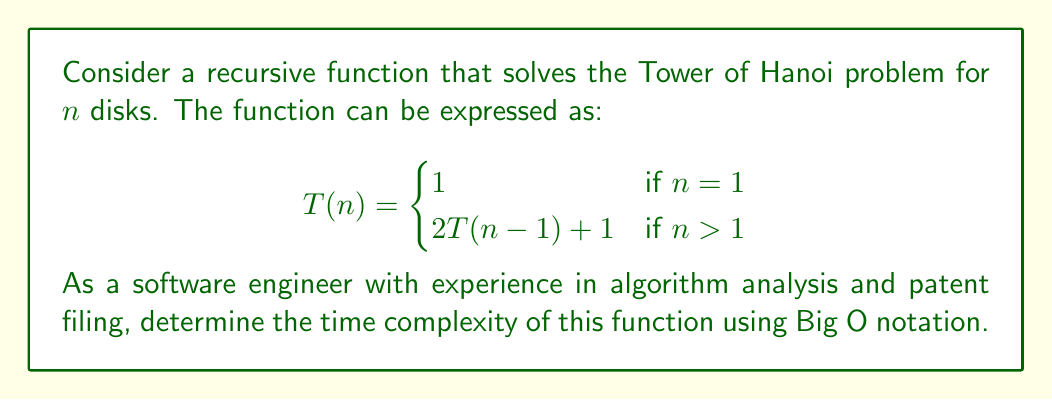Show me your answer to this math problem. To determine the time complexity, let's solve the recurrence relation:

1) First, let's expand the recurrence a few times:
   $T(n) = 2T(n-1) + 1$
   $= 2(2T(n-2) + 1) + 1 = 2^2T(n-2) + 2 + 1$
   $= 2^2(2T(n-3) + 1) + 2 + 1 = 2^3T(n-3) + 2^2 + 2 + 1$

2) We can see a pattern forming. After $k$ expansions:
   $T(n) = 2^kT(n-k) + 2^{k-1} + 2^{k-2} + ... + 2^1 + 2^0$

3) The process stops when $n-k = 1$, i.e., when $k = n-1$:
   $T(n) = 2^{n-1}T(1) + 2^{n-2} + 2^{n-3} + ... + 2^1 + 2^0$

4) We know that $T(1) = 1$, so:
   $T(n) = 2^{n-1} + 2^{n-2} + 2^{n-3} + ... + 2^1 + 2^0$

5) This is a geometric series with $n$ terms, first term $a=1$, and common ratio $r=2$. The sum of such a series is given by $\frac{a(1-r^n)}{1-r} = 2^n - 1$

6) Therefore, $T(n) = 2^n - 1$

7) In Big O notation, we ignore constants and lower-order terms, so:
   $T(n) = O(2^n)$

Thus, the time complexity of the function is exponential.
Answer: $O(2^n)$ 